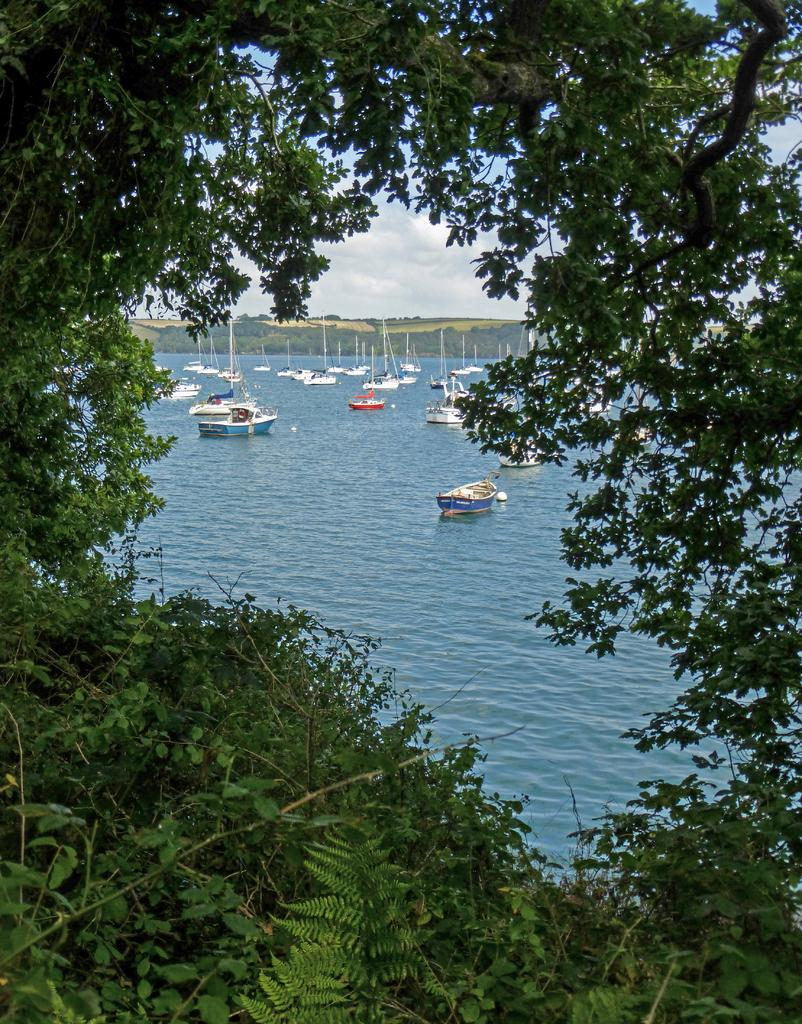What can be seen on the surface of the water in the image? There are ships on the surface of water in the image. What type of vegetation is present in the foreground of the image? There is greenery in the foreground of the image. What is visible in the background of the image? The sky is visible in the background of the image. What can be observed in the sky? There are clouds in the sky. What type of silk is being used to make the grass in the image? There is no silk present in the image, and the grass is not made of silk. How does the beginner navigate the ships in the image? There is no indication of a beginner or navigation in the image; it simply shows ships on the water. 